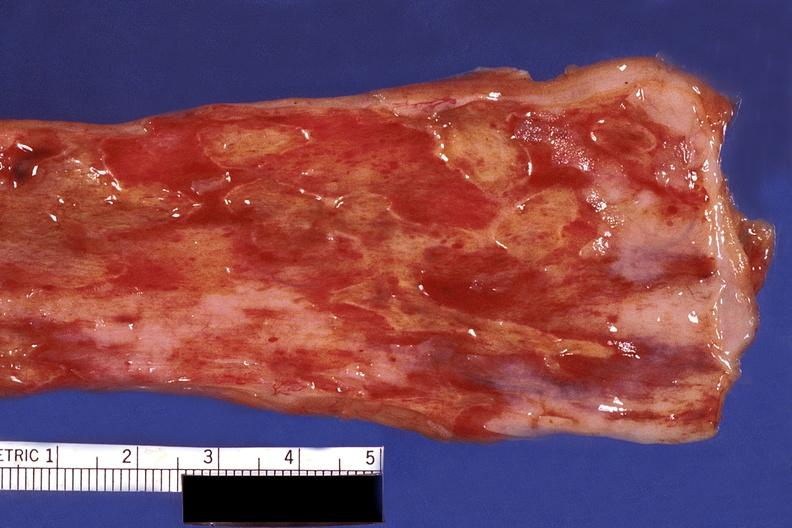does fibrinous peritonitis show esophagus, herpes, ulcers?
Answer the question using a single word or phrase. No 